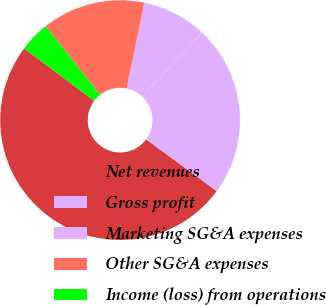Convert chart to OTSL. <chart><loc_0><loc_0><loc_500><loc_500><pie_chart><fcel>Net revenues<fcel>Gross profit<fcel>Marketing SG&A expenses<fcel>Other SG&A expenses<fcel>Income (loss) from operations<nl><fcel>50.13%<fcel>23.11%<fcel>8.73%<fcel>13.89%<fcel>4.13%<nl></chart> 